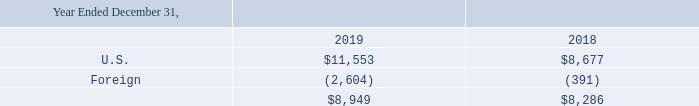Note 5: Income Taxes
On December 22, 2017, the U.S. government enacted the Tax Cuts and Jobs Act (the “Tax Act”). The Tax Act includes significant changes to the U.S. corporate income tax system including: a federal corporate rate reduction from 35% to 21%; limitations on the deductibility of interest expense and executive compensation; creation of the base erosion anti-abuse tax (“BEAT”), a new minimum tax; and the transition of U.S. international taxation from a worldwide tax system to a modified territorial tax system. The change to a modified territorial tax system resulted in a one-time U.S. tax liability on those earnings which have not previously been repatriated to the U.S. (the “Transition Tax”), with future distributions not subject to U.S. federal income tax when repatriated. A majority of the provisions in the Tax Act are effective January 1, 2018.
In response to the Tax Act, the SEC staff issued guidance on accounting for the tax effects of the Tax Act. The guidance provides a one-year measurement period for companies to complete the accounting. The Company reflected the income tax effects of those aspects of the Tax Act for which the accounting is complete. To the extent a company's accounting for certain income tax effects of the Tax Act is incomplete but it is able to determine a reasonable estimate, a company should record a provisional estimate in the financial statements. If a company cannot determine a provisional estimate to be included in the financial statements, it should continue to apply the provisions of the tax laws that were in effect immediately before the enactment of the Tax Act.
In connection with the Company's initial analysis of the impact of the Tax Act, the Company has recorded a provisional estimate of discrete net tax expense of $508,000 for the period ended December 31, 2017. This discrete expense consists of provisional estimates of zero expense for the Transition Tax, $173,000 net benefit for the decrease in the Company's deferred tax liability on unremitted foreign earnings, and $681,000 net expense for remeasurement of the Company's deferred tax assets and liabilities for the corporate rate reduction.
During the year ended December 31, 2018, we completed our accounting for the income tax effects of the Tax Act. We did not recognize any additional discrete net tax expense in addition to the provisional amounts recorded at December 31, 2017 for the enactment-date effects of the Tax Act, for a total of $508,000 of discrete net tax expense.
As of December 31, 2019, the Company is permanently reinvested in certain Non-U.S. subsidiaries and does not have a deferred tax liability related to its undistributed foreign earnings. The estimated amount of the unrecognized deferred tax liability attributed to future withholding taxes on dividend distributions of undistributed earnings for certain non-U.S. subsidiaries, which the Company intends to reinvest the related earnings indefinitely in its operations outside the U.S., is approximately $484,000 at December 31, 2019
The components of income before income tax expense are as follows (in thousands):
When did the U.S. government enact the Tax Cuts and Jobs Act? December 22, 2017. What is the income before income tax expense for U.S. in 2019 and 2018 respectively?
Answer scale should be: thousand. $11,553, $8,677. What is the income before income tax expense for foreign in 2019 and 2018 respectively?
Answer scale should be: thousand. (2,604), (391). What is the change in the income before income tax expense for U.S. between 2018 and 2019?
Answer scale should be: thousand. 11,553-8,677
Answer: 2876. What is the percentage change in the income before income tax expense for U.S. between 2018 and 2019?
Answer scale should be: percent. (11,553-8,677)/8,677
Answer: 33.15. What is the average of the total income before income tax expense for 2018 and 2019?
Answer scale should be: thousand. (8,949+ 8,286)/2
Answer: 8617.5. 